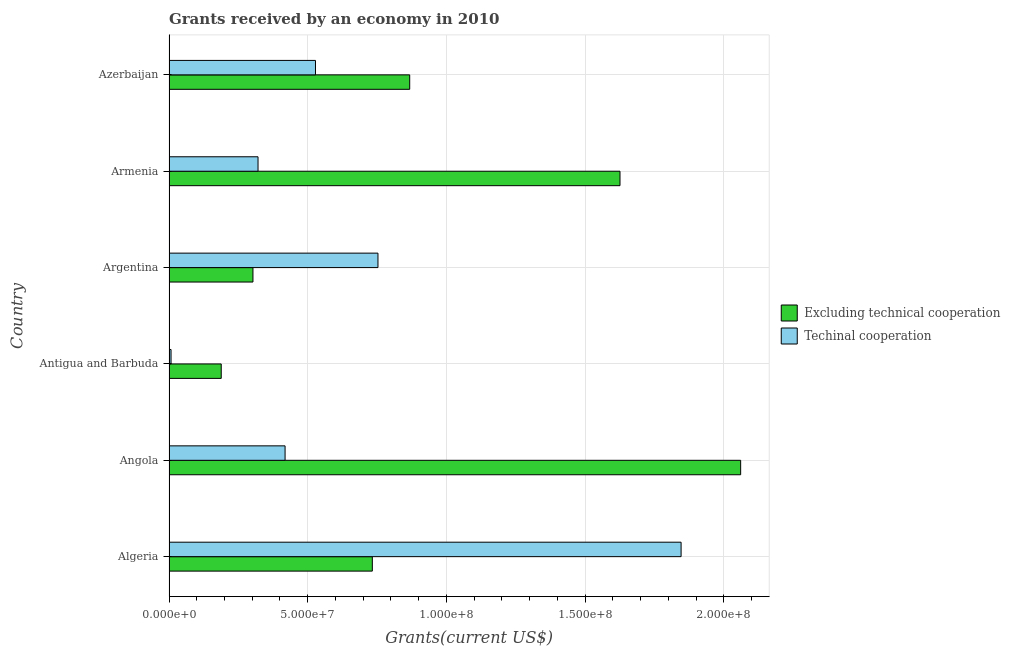How many different coloured bars are there?
Your response must be concise. 2. How many groups of bars are there?
Your answer should be very brief. 6. How many bars are there on the 2nd tick from the top?
Your answer should be compact. 2. What is the label of the 6th group of bars from the top?
Your response must be concise. Algeria. What is the amount of grants received(including technical cooperation) in Angola?
Provide a succinct answer. 4.18e+07. Across all countries, what is the maximum amount of grants received(including technical cooperation)?
Give a very brief answer. 1.85e+08. Across all countries, what is the minimum amount of grants received(including technical cooperation)?
Offer a very short reply. 7.40e+05. In which country was the amount of grants received(excluding technical cooperation) maximum?
Make the answer very short. Angola. In which country was the amount of grants received(including technical cooperation) minimum?
Ensure brevity in your answer.  Antigua and Barbuda. What is the total amount of grants received(excluding technical cooperation) in the graph?
Provide a short and direct response. 5.78e+08. What is the difference between the amount of grants received(excluding technical cooperation) in Algeria and that in Antigua and Barbuda?
Offer a terse response. 5.45e+07. What is the difference between the amount of grants received(excluding technical cooperation) in Angola and the amount of grants received(including technical cooperation) in Argentina?
Give a very brief answer. 1.31e+08. What is the average amount of grants received(excluding technical cooperation) per country?
Ensure brevity in your answer.  9.63e+07. What is the difference between the amount of grants received(excluding technical cooperation) and amount of grants received(including technical cooperation) in Antigua and Barbuda?
Your answer should be compact. 1.81e+07. In how many countries, is the amount of grants received(including technical cooperation) greater than 120000000 US$?
Offer a very short reply. 1. What is the ratio of the amount of grants received(including technical cooperation) in Algeria to that in Azerbaijan?
Give a very brief answer. 3.5. Is the difference between the amount of grants received(including technical cooperation) in Antigua and Barbuda and Azerbaijan greater than the difference between the amount of grants received(excluding technical cooperation) in Antigua and Barbuda and Azerbaijan?
Your answer should be compact. Yes. What is the difference between the highest and the second highest amount of grants received(excluding technical cooperation)?
Your answer should be very brief. 4.35e+07. What is the difference between the highest and the lowest amount of grants received(including technical cooperation)?
Give a very brief answer. 1.84e+08. In how many countries, is the amount of grants received(including technical cooperation) greater than the average amount of grants received(including technical cooperation) taken over all countries?
Provide a succinct answer. 2. What does the 1st bar from the top in Antigua and Barbuda represents?
Offer a terse response. Techinal cooperation. What does the 1st bar from the bottom in Antigua and Barbuda represents?
Your answer should be very brief. Excluding technical cooperation. How many bars are there?
Ensure brevity in your answer.  12. Does the graph contain any zero values?
Ensure brevity in your answer.  No. Does the graph contain grids?
Your answer should be compact. Yes. What is the title of the graph?
Your answer should be very brief. Grants received by an economy in 2010. What is the label or title of the X-axis?
Keep it short and to the point. Grants(current US$). What is the label or title of the Y-axis?
Provide a succinct answer. Country. What is the Grants(current US$) of Excluding technical cooperation in Algeria?
Keep it short and to the point. 7.33e+07. What is the Grants(current US$) of Techinal cooperation in Algeria?
Keep it short and to the point. 1.85e+08. What is the Grants(current US$) of Excluding technical cooperation in Angola?
Offer a very short reply. 2.06e+08. What is the Grants(current US$) in Techinal cooperation in Angola?
Offer a very short reply. 4.18e+07. What is the Grants(current US$) of Excluding technical cooperation in Antigua and Barbuda?
Your answer should be compact. 1.88e+07. What is the Grants(current US$) of Techinal cooperation in Antigua and Barbuda?
Provide a short and direct response. 7.40e+05. What is the Grants(current US$) of Excluding technical cooperation in Argentina?
Keep it short and to the point. 3.03e+07. What is the Grants(current US$) in Techinal cooperation in Argentina?
Your response must be concise. 7.53e+07. What is the Grants(current US$) of Excluding technical cooperation in Armenia?
Provide a succinct answer. 1.63e+08. What is the Grants(current US$) in Techinal cooperation in Armenia?
Your answer should be compact. 3.21e+07. What is the Grants(current US$) in Excluding technical cooperation in Azerbaijan?
Offer a very short reply. 8.68e+07. What is the Grants(current US$) of Techinal cooperation in Azerbaijan?
Your answer should be very brief. 5.28e+07. Across all countries, what is the maximum Grants(current US$) in Excluding technical cooperation?
Ensure brevity in your answer.  2.06e+08. Across all countries, what is the maximum Grants(current US$) of Techinal cooperation?
Your answer should be compact. 1.85e+08. Across all countries, what is the minimum Grants(current US$) of Excluding technical cooperation?
Offer a terse response. 1.88e+07. Across all countries, what is the minimum Grants(current US$) in Techinal cooperation?
Your answer should be compact. 7.40e+05. What is the total Grants(current US$) of Excluding technical cooperation in the graph?
Provide a short and direct response. 5.78e+08. What is the total Grants(current US$) in Techinal cooperation in the graph?
Your answer should be compact. 3.87e+08. What is the difference between the Grants(current US$) in Excluding technical cooperation in Algeria and that in Angola?
Offer a very short reply. -1.33e+08. What is the difference between the Grants(current US$) in Techinal cooperation in Algeria and that in Angola?
Make the answer very short. 1.43e+08. What is the difference between the Grants(current US$) of Excluding technical cooperation in Algeria and that in Antigua and Barbuda?
Give a very brief answer. 5.45e+07. What is the difference between the Grants(current US$) of Techinal cooperation in Algeria and that in Antigua and Barbuda?
Give a very brief answer. 1.84e+08. What is the difference between the Grants(current US$) in Excluding technical cooperation in Algeria and that in Argentina?
Ensure brevity in your answer.  4.30e+07. What is the difference between the Grants(current US$) of Techinal cooperation in Algeria and that in Argentina?
Offer a terse response. 1.09e+08. What is the difference between the Grants(current US$) of Excluding technical cooperation in Algeria and that in Armenia?
Offer a very short reply. -8.93e+07. What is the difference between the Grants(current US$) of Techinal cooperation in Algeria and that in Armenia?
Make the answer very short. 1.52e+08. What is the difference between the Grants(current US$) of Excluding technical cooperation in Algeria and that in Azerbaijan?
Your answer should be very brief. -1.35e+07. What is the difference between the Grants(current US$) of Techinal cooperation in Algeria and that in Azerbaijan?
Offer a terse response. 1.32e+08. What is the difference between the Grants(current US$) of Excluding technical cooperation in Angola and that in Antigua and Barbuda?
Provide a succinct answer. 1.87e+08. What is the difference between the Grants(current US$) of Techinal cooperation in Angola and that in Antigua and Barbuda?
Keep it short and to the point. 4.11e+07. What is the difference between the Grants(current US$) in Excluding technical cooperation in Angola and that in Argentina?
Make the answer very short. 1.76e+08. What is the difference between the Grants(current US$) in Techinal cooperation in Angola and that in Argentina?
Give a very brief answer. -3.35e+07. What is the difference between the Grants(current US$) in Excluding technical cooperation in Angola and that in Armenia?
Your response must be concise. 4.35e+07. What is the difference between the Grants(current US$) of Techinal cooperation in Angola and that in Armenia?
Keep it short and to the point. 9.75e+06. What is the difference between the Grants(current US$) in Excluding technical cooperation in Angola and that in Azerbaijan?
Give a very brief answer. 1.19e+08. What is the difference between the Grants(current US$) of Techinal cooperation in Angola and that in Azerbaijan?
Ensure brevity in your answer.  -1.10e+07. What is the difference between the Grants(current US$) of Excluding technical cooperation in Antigua and Barbuda and that in Argentina?
Keep it short and to the point. -1.14e+07. What is the difference between the Grants(current US$) in Techinal cooperation in Antigua and Barbuda and that in Argentina?
Offer a terse response. -7.46e+07. What is the difference between the Grants(current US$) in Excluding technical cooperation in Antigua and Barbuda and that in Armenia?
Offer a terse response. -1.44e+08. What is the difference between the Grants(current US$) of Techinal cooperation in Antigua and Barbuda and that in Armenia?
Provide a short and direct response. -3.14e+07. What is the difference between the Grants(current US$) of Excluding technical cooperation in Antigua and Barbuda and that in Azerbaijan?
Your answer should be very brief. -6.79e+07. What is the difference between the Grants(current US$) in Techinal cooperation in Antigua and Barbuda and that in Azerbaijan?
Keep it short and to the point. -5.21e+07. What is the difference between the Grants(current US$) in Excluding technical cooperation in Argentina and that in Armenia?
Keep it short and to the point. -1.32e+08. What is the difference between the Grants(current US$) of Techinal cooperation in Argentina and that in Armenia?
Give a very brief answer. 4.32e+07. What is the difference between the Grants(current US$) in Excluding technical cooperation in Argentina and that in Azerbaijan?
Offer a terse response. -5.65e+07. What is the difference between the Grants(current US$) in Techinal cooperation in Argentina and that in Azerbaijan?
Your answer should be very brief. 2.25e+07. What is the difference between the Grants(current US$) in Excluding technical cooperation in Armenia and that in Azerbaijan?
Your answer should be compact. 7.58e+07. What is the difference between the Grants(current US$) of Techinal cooperation in Armenia and that in Azerbaijan?
Provide a short and direct response. -2.07e+07. What is the difference between the Grants(current US$) in Excluding technical cooperation in Algeria and the Grants(current US$) in Techinal cooperation in Angola?
Provide a succinct answer. 3.14e+07. What is the difference between the Grants(current US$) in Excluding technical cooperation in Algeria and the Grants(current US$) in Techinal cooperation in Antigua and Barbuda?
Give a very brief answer. 7.26e+07. What is the difference between the Grants(current US$) in Excluding technical cooperation in Algeria and the Grants(current US$) in Techinal cooperation in Argentina?
Your response must be concise. -2.03e+06. What is the difference between the Grants(current US$) in Excluding technical cooperation in Algeria and the Grants(current US$) in Techinal cooperation in Armenia?
Ensure brevity in your answer.  4.12e+07. What is the difference between the Grants(current US$) of Excluding technical cooperation in Algeria and the Grants(current US$) of Techinal cooperation in Azerbaijan?
Offer a terse response. 2.05e+07. What is the difference between the Grants(current US$) in Excluding technical cooperation in Angola and the Grants(current US$) in Techinal cooperation in Antigua and Barbuda?
Provide a succinct answer. 2.05e+08. What is the difference between the Grants(current US$) of Excluding technical cooperation in Angola and the Grants(current US$) of Techinal cooperation in Argentina?
Ensure brevity in your answer.  1.31e+08. What is the difference between the Grants(current US$) of Excluding technical cooperation in Angola and the Grants(current US$) of Techinal cooperation in Armenia?
Your response must be concise. 1.74e+08. What is the difference between the Grants(current US$) of Excluding technical cooperation in Angola and the Grants(current US$) of Techinal cooperation in Azerbaijan?
Offer a very short reply. 1.53e+08. What is the difference between the Grants(current US$) of Excluding technical cooperation in Antigua and Barbuda and the Grants(current US$) of Techinal cooperation in Argentina?
Your answer should be very brief. -5.65e+07. What is the difference between the Grants(current US$) of Excluding technical cooperation in Antigua and Barbuda and the Grants(current US$) of Techinal cooperation in Armenia?
Make the answer very short. -1.33e+07. What is the difference between the Grants(current US$) of Excluding technical cooperation in Antigua and Barbuda and the Grants(current US$) of Techinal cooperation in Azerbaijan?
Provide a short and direct response. -3.40e+07. What is the difference between the Grants(current US$) in Excluding technical cooperation in Argentina and the Grants(current US$) in Techinal cooperation in Armenia?
Your answer should be very brief. -1.83e+06. What is the difference between the Grants(current US$) in Excluding technical cooperation in Argentina and the Grants(current US$) in Techinal cooperation in Azerbaijan?
Make the answer very short. -2.25e+07. What is the difference between the Grants(current US$) in Excluding technical cooperation in Armenia and the Grants(current US$) in Techinal cooperation in Azerbaijan?
Your answer should be very brief. 1.10e+08. What is the average Grants(current US$) in Excluding technical cooperation per country?
Offer a very short reply. 9.63e+07. What is the average Grants(current US$) in Techinal cooperation per country?
Your answer should be compact. 6.46e+07. What is the difference between the Grants(current US$) in Excluding technical cooperation and Grants(current US$) in Techinal cooperation in Algeria?
Your response must be concise. -1.11e+08. What is the difference between the Grants(current US$) in Excluding technical cooperation and Grants(current US$) in Techinal cooperation in Angola?
Your answer should be compact. 1.64e+08. What is the difference between the Grants(current US$) in Excluding technical cooperation and Grants(current US$) in Techinal cooperation in Antigua and Barbuda?
Provide a short and direct response. 1.81e+07. What is the difference between the Grants(current US$) in Excluding technical cooperation and Grants(current US$) in Techinal cooperation in Argentina?
Make the answer very short. -4.51e+07. What is the difference between the Grants(current US$) of Excluding technical cooperation and Grants(current US$) of Techinal cooperation in Armenia?
Offer a very short reply. 1.30e+08. What is the difference between the Grants(current US$) in Excluding technical cooperation and Grants(current US$) in Techinal cooperation in Azerbaijan?
Give a very brief answer. 3.40e+07. What is the ratio of the Grants(current US$) in Excluding technical cooperation in Algeria to that in Angola?
Provide a short and direct response. 0.36. What is the ratio of the Grants(current US$) in Techinal cooperation in Algeria to that in Angola?
Provide a succinct answer. 4.41. What is the ratio of the Grants(current US$) of Excluding technical cooperation in Algeria to that in Antigua and Barbuda?
Make the answer very short. 3.89. What is the ratio of the Grants(current US$) in Techinal cooperation in Algeria to that in Antigua and Barbuda?
Give a very brief answer. 249.43. What is the ratio of the Grants(current US$) of Excluding technical cooperation in Algeria to that in Argentina?
Offer a very short reply. 2.42. What is the ratio of the Grants(current US$) in Techinal cooperation in Algeria to that in Argentina?
Offer a very short reply. 2.45. What is the ratio of the Grants(current US$) in Excluding technical cooperation in Algeria to that in Armenia?
Your answer should be very brief. 0.45. What is the ratio of the Grants(current US$) of Techinal cooperation in Algeria to that in Armenia?
Your answer should be very brief. 5.75. What is the ratio of the Grants(current US$) of Excluding technical cooperation in Algeria to that in Azerbaijan?
Offer a very short reply. 0.84. What is the ratio of the Grants(current US$) of Techinal cooperation in Algeria to that in Azerbaijan?
Your answer should be compact. 3.5. What is the ratio of the Grants(current US$) in Excluding technical cooperation in Angola to that in Antigua and Barbuda?
Your response must be concise. 10.94. What is the ratio of the Grants(current US$) in Techinal cooperation in Angola to that in Antigua and Barbuda?
Offer a very short reply. 56.54. What is the ratio of the Grants(current US$) of Excluding technical cooperation in Angola to that in Argentina?
Keep it short and to the point. 6.81. What is the ratio of the Grants(current US$) in Techinal cooperation in Angola to that in Argentina?
Keep it short and to the point. 0.56. What is the ratio of the Grants(current US$) of Excluding technical cooperation in Angola to that in Armenia?
Your answer should be very brief. 1.27. What is the ratio of the Grants(current US$) of Techinal cooperation in Angola to that in Armenia?
Ensure brevity in your answer.  1.3. What is the ratio of the Grants(current US$) of Excluding technical cooperation in Angola to that in Azerbaijan?
Your response must be concise. 2.37. What is the ratio of the Grants(current US$) of Techinal cooperation in Angola to that in Azerbaijan?
Your answer should be very brief. 0.79. What is the ratio of the Grants(current US$) in Excluding technical cooperation in Antigua and Barbuda to that in Argentina?
Offer a very short reply. 0.62. What is the ratio of the Grants(current US$) of Techinal cooperation in Antigua and Barbuda to that in Argentina?
Ensure brevity in your answer.  0.01. What is the ratio of the Grants(current US$) of Excluding technical cooperation in Antigua and Barbuda to that in Armenia?
Your answer should be very brief. 0.12. What is the ratio of the Grants(current US$) of Techinal cooperation in Antigua and Barbuda to that in Armenia?
Keep it short and to the point. 0.02. What is the ratio of the Grants(current US$) of Excluding technical cooperation in Antigua and Barbuda to that in Azerbaijan?
Your answer should be compact. 0.22. What is the ratio of the Grants(current US$) in Techinal cooperation in Antigua and Barbuda to that in Azerbaijan?
Keep it short and to the point. 0.01. What is the ratio of the Grants(current US$) of Excluding technical cooperation in Argentina to that in Armenia?
Ensure brevity in your answer.  0.19. What is the ratio of the Grants(current US$) of Techinal cooperation in Argentina to that in Armenia?
Provide a short and direct response. 2.35. What is the ratio of the Grants(current US$) of Excluding technical cooperation in Argentina to that in Azerbaijan?
Offer a very short reply. 0.35. What is the ratio of the Grants(current US$) in Techinal cooperation in Argentina to that in Azerbaijan?
Your answer should be very brief. 1.43. What is the ratio of the Grants(current US$) of Excluding technical cooperation in Armenia to that in Azerbaijan?
Provide a short and direct response. 1.87. What is the ratio of the Grants(current US$) in Techinal cooperation in Armenia to that in Azerbaijan?
Offer a very short reply. 0.61. What is the difference between the highest and the second highest Grants(current US$) of Excluding technical cooperation?
Provide a succinct answer. 4.35e+07. What is the difference between the highest and the second highest Grants(current US$) of Techinal cooperation?
Keep it short and to the point. 1.09e+08. What is the difference between the highest and the lowest Grants(current US$) in Excluding technical cooperation?
Give a very brief answer. 1.87e+08. What is the difference between the highest and the lowest Grants(current US$) in Techinal cooperation?
Offer a very short reply. 1.84e+08. 